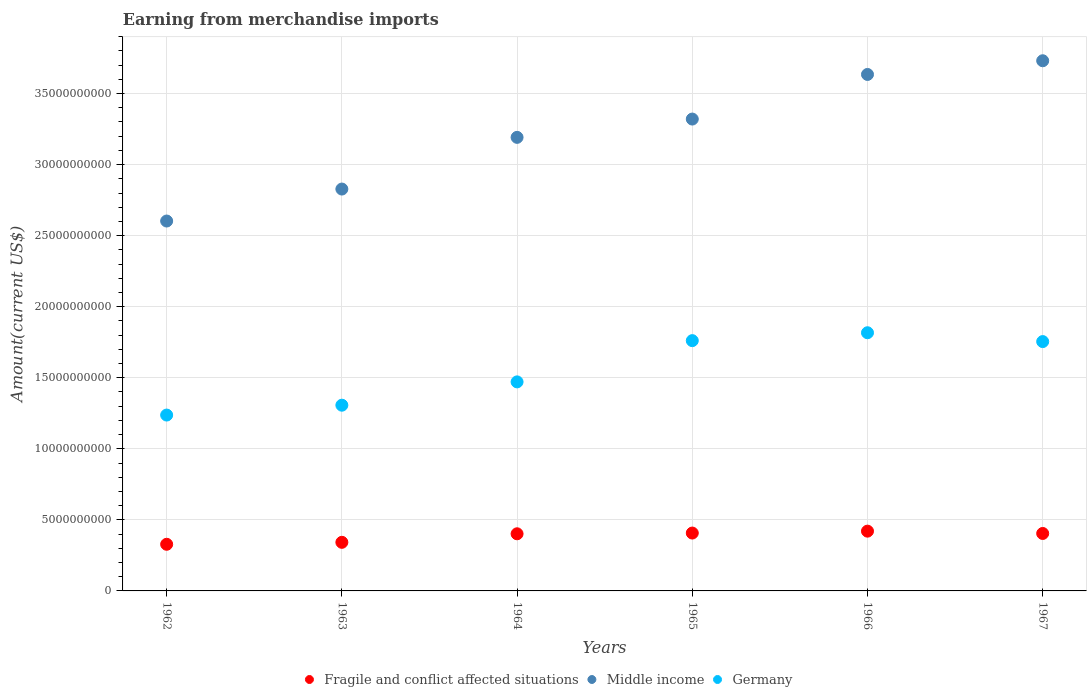How many different coloured dotlines are there?
Make the answer very short. 3. What is the amount earned from merchandise imports in Middle income in 1966?
Make the answer very short. 3.63e+1. Across all years, what is the maximum amount earned from merchandise imports in Germany?
Offer a very short reply. 1.82e+1. Across all years, what is the minimum amount earned from merchandise imports in Fragile and conflict affected situations?
Keep it short and to the point. 3.28e+09. In which year was the amount earned from merchandise imports in Germany maximum?
Give a very brief answer. 1966. What is the total amount earned from merchandise imports in Fragile and conflict affected situations in the graph?
Your answer should be very brief. 2.30e+1. What is the difference between the amount earned from merchandise imports in Germany in 1962 and that in 1965?
Offer a very short reply. -5.24e+09. What is the difference between the amount earned from merchandise imports in Middle income in 1962 and the amount earned from merchandise imports in Fragile and conflict affected situations in 1964?
Provide a succinct answer. 2.20e+1. What is the average amount earned from merchandise imports in Germany per year?
Your response must be concise. 1.56e+1. In the year 1967, what is the difference between the amount earned from merchandise imports in Middle income and amount earned from merchandise imports in Germany?
Provide a short and direct response. 1.98e+1. What is the ratio of the amount earned from merchandise imports in Fragile and conflict affected situations in 1962 to that in 1966?
Keep it short and to the point. 0.78. What is the difference between the highest and the second highest amount earned from merchandise imports in Germany?
Offer a very short reply. 5.55e+08. What is the difference between the highest and the lowest amount earned from merchandise imports in Germany?
Offer a terse response. 5.79e+09. Is it the case that in every year, the sum of the amount earned from merchandise imports in Fragile and conflict affected situations and amount earned from merchandise imports in Germany  is greater than the amount earned from merchandise imports in Middle income?
Keep it short and to the point. No. Does the amount earned from merchandise imports in Germany monotonically increase over the years?
Provide a succinct answer. No. Are the values on the major ticks of Y-axis written in scientific E-notation?
Offer a terse response. No. How many legend labels are there?
Your answer should be compact. 3. What is the title of the graph?
Give a very brief answer. Earning from merchandise imports. Does "Cote d'Ivoire" appear as one of the legend labels in the graph?
Provide a succinct answer. No. What is the label or title of the Y-axis?
Your response must be concise. Amount(current US$). What is the Amount(current US$) of Fragile and conflict affected situations in 1962?
Your response must be concise. 3.28e+09. What is the Amount(current US$) in Middle income in 1962?
Your answer should be compact. 2.60e+1. What is the Amount(current US$) in Germany in 1962?
Your answer should be very brief. 1.24e+1. What is the Amount(current US$) of Fragile and conflict affected situations in 1963?
Your response must be concise. 3.42e+09. What is the Amount(current US$) of Middle income in 1963?
Your answer should be compact. 2.83e+1. What is the Amount(current US$) of Germany in 1963?
Your response must be concise. 1.31e+1. What is the Amount(current US$) in Fragile and conflict affected situations in 1964?
Offer a very short reply. 4.02e+09. What is the Amount(current US$) in Middle income in 1964?
Offer a very short reply. 3.19e+1. What is the Amount(current US$) of Germany in 1964?
Offer a very short reply. 1.47e+1. What is the Amount(current US$) in Fragile and conflict affected situations in 1965?
Make the answer very short. 4.07e+09. What is the Amount(current US$) in Middle income in 1965?
Provide a short and direct response. 3.32e+1. What is the Amount(current US$) in Germany in 1965?
Provide a succinct answer. 1.76e+1. What is the Amount(current US$) of Fragile and conflict affected situations in 1966?
Give a very brief answer. 4.21e+09. What is the Amount(current US$) of Middle income in 1966?
Offer a very short reply. 3.63e+1. What is the Amount(current US$) of Germany in 1966?
Give a very brief answer. 1.82e+1. What is the Amount(current US$) of Fragile and conflict affected situations in 1967?
Provide a short and direct response. 4.04e+09. What is the Amount(current US$) in Middle income in 1967?
Your answer should be very brief. 3.73e+1. What is the Amount(current US$) in Germany in 1967?
Ensure brevity in your answer.  1.75e+1. Across all years, what is the maximum Amount(current US$) of Fragile and conflict affected situations?
Ensure brevity in your answer.  4.21e+09. Across all years, what is the maximum Amount(current US$) of Middle income?
Offer a very short reply. 3.73e+1. Across all years, what is the maximum Amount(current US$) of Germany?
Ensure brevity in your answer.  1.82e+1. Across all years, what is the minimum Amount(current US$) of Fragile and conflict affected situations?
Your response must be concise. 3.28e+09. Across all years, what is the minimum Amount(current US$) of Middle income?
Provide a succinct answer. 2.60e+1. Across all years, what is the minimum Amount(current US$) in Germany?
Offer a very short reply. 1.24e+1. What is the total Amount(current US$) of Fragile and conflict affected situations in the graph?
Offer a terse response. 2.30e+1. What is the total Amount(current US$) in Middle income in the graph?
Your answer should be very brief. 1.93e+11. What is the total Amount(current US$) of Germany in the graph?
Provide a succinct answer. 9.35e+1. What is the difference between the Amount(current US$) in Fragile and conflict affected situations in 1962 and that in 1963?
Provide a succinct answer. -1.38e+08. What is the difference between the Amount(current US$) in Middle income in 1962 and that in 1963?
Your answer should be very brief. -2.25e+09. What is the difference between the Amount(current US$) of Germany in 1962 and that in 1963?
Give a very brief answer. -6.94e+08. What is the difference between the Amount(current US$) of Fragile and conflict affected situations in 1962 and that in 1964?
Keep it short and to the point. -7.38e+08. What is the difference between the Amount(current US$) of Middle income in 1962 and that in 1964?
Ensure brevity in your answer.  -5.89e+09. What is the difference between the Amount(current US$) in Germany in 1962 and that in 1964?
Provide a succinct answer. -2.33e+09. What is the difference between the Amount(current US$) of Fragile and conflict affected situations in 1962 and that in 1965?
Make the answer very short. -7.90e+08. What is the difference between the Amount(current US$) in Middle income in 1962 and that in 1965?
Your answer should be compact. -7.17e+09. What is the difference between the Amount(current US$) in Germany in 1962 and that in 1965?
Your answer should be compact. -5.24e+09. What is the difference between the Amount(current US$) in Fragile and conflict affected situations in 1962 and that in 1966?
Make the answer very short. -9.24e+08. What is the difference between the Amount(current US$) in Middle income in 1962 and that in 1966?
Keep it short and to the point. -1.03e+1. What is the difference between the Amount(current US$) in Germany in 1962 and that in 1966?
Provide a succinct answer. -5.79e+09. What is the difference between the Amount(current US$) of Fragile and conflict affected situations in 1962 and that in 1967?
Provide a succinct answer. -7.61e+08. What is the difference between the Amount(current US$) of Middle income in 1962 and that in 1967?
Give a very brief answer. -1.13e+1. What is the difference between the Amount(current US$) in Germany in 1962 and that in 1967?
Offer a very short reply. -5.17e+09. What is the difference between the Amount(current US$) in Fragile and conflict affected situations in 1963 and that in 1964?
Provide a succinct answer. -6.00e+08. What is the difference between the Amount(current US$) in Middle income in 1963 and that in 1964?
Offer a very short reply. -3.64e+09. What is the difference between the Amount(current US$) in Germany in 1963 and that in 1964?
Your answer should be very brief. -1.64e+09. What is the difference between the Amount(current US$) in Fragile and conflict affected situations in 1963 and that in 1965?
Provide a short and direct response. -6.53e+08. What is the difference between the Amount(current US$) in Middle income in 1963 and that in 1965?
Your answer should be very brief. -4.93e+09. What is the difference between the Amount(current US$) of Germany in 1963 and that in 1965?
Your response must be concise. -4.54e+09. What is the difference between the Amount(current US$) in Fragile and conflict affected situations in 1963 and that in 1966?
Offer a very short reply. -7.86e+08. What is the difference between the Amount(current US$) of Middle income in 1963 and that in 1966?
Offer a very short reply. -8.06e+09. What is the difference between the Amount(current US$) of Germany in 1963 and that in 1966?
Your answer should be compact. -5.10e+09. What is the difference between the Amount(current US$) in Fragile and conflict affected situations in 1963 and that in 1967?
Provide a succinct answer. -6.23e+08. What is the difference between the Amount(current US$) in Middle income in 1963 and that in 1967?
Give a very brief answer. -9.03e+09. What is the difference between the Amount(current US$) of Germany in 1963 and that in 1967?
Provide a short and direct response. -4.48e+09. What is the difference between the Amount(current US$) in Fragile and conflict affected situations in 1964 and that in 1965?
Keep it short and to the point. -5.24e+07. What is the difference between the Amount(current US$) of Middle income in 1964 and that in 1965?
Make the answer very short. -1.29e+09. What is the difference between the Amount(current US$) in Germany in 1964 and that in 1965?
Your answer should be very brief. -2.90e+09. What is the difference between the Amount(current US$) in Fragile and conflict affected situations in 1964 and that in 1966?
Make the answer very short. -1.86e+08. What is the difference between the Amount(current US$) of Middle income in 1964 and that in 1966?
Keep it short and to the point. -4.43e+09. What is the difference between the Amount(current US$) of Germany in 1964 and that in 1966?
Ensure brevity in your answer.  -3.46e+09. What is the difference between the Amount(current US$) in Fragile and conflict affected situations in 1964 and that in 1967?
Give a very brief answer. -2.29e+07. What is the difference between the Amount(current US$) of Middle income in 1964 and that in 1967?
Your response must be concise. -5.39e+09. What is the difference between the Amount(current US$) in Germany in 1964 and that in 1967?
Keep it short and to the point. -2.84e+09. What is the difference between the Amount(current US$) of Fragile and conflict affected situations in 1965 and that in 1966?
Provide a succinct answer. -1.33e+08. What is the difference between the Amount(current US$) of Middle income in 1965 and that in 1966?
Your answer should be compact. -3.14e+09. What is the difference between the Amount(current US$) in Germany in 1965 and that in 1966?
Provide a short and direct response. -5.55e+08. What is the difference between the Amount(current US$) of Fragile and conflict affected situations in 1965 and that in 1967?
Ensure brevity in your answer.  2.96e+07. What is the difference between the Amount(current US$) in Middle income in 1965 and that in 1967?
Your response must be concise. -4.10e+09. What is the difference between the Amount(current US$) of Germany in 1965 and that in 1967?
Your answer should be compact. 6.65e+07. What is the difference between the Amount(current US$) of Fragile and conflict affected situations in 1966 and that in 1967?
Your response must be concise. 1.63e+08. What is the difference between the Amount(current US$) of Middle income in 1966 and that in 1967?
Your answer should be compact. -9.64e+08. What is the difference between the Amount(current US$) in Germany in 1966 and that in 1967?
Your response must be concise. 6.22e+08. What is the difference between the Amount(current US$) of Fragile and conflict affected situations in 1962 and the Amount(current US$) of Middle income in 1963?
Your response must be concise. -2.50e+1. What is the difference between the Amount(current US$) in Fragile and conflict affected situations in 1962 and the Amount(current US$) in Germany in 1963?
Ensure brevity in your answer.  -9.79e+09. What is the difference between the Amount(current US$) of Middle income in 1962 and the Amount(current US$) of Germany in 1963?
Make the answer very short. 1.30e+1. What is the difference between the Amount(current US$) in Fragile and conflict affected situations in 1962 and the Amount(current US$) in Middle income in 1964?
Your answer should be very brief. -2.86e+1. What is the difference between the Amount(current US$) of Fragile and conflict affected situations in 1962 and the Amount(current US$) of Germany in 1964?
Give a very brief answer. -1.14e+1. What is the difference between the Amount(current US$) in Middle income in 1962 and the Amount(current US$) in Germany in 1964?
Ensure brevity in your answer.  1.13e+1. What is the difference between the Amount(current US$) in Fragile and conflict affected situations in 1962 and the Amount(current US$) in Middle income in 1965?
Provide a succinct answer. -2.99e+1. What is the difference between the Amount(current US$) in Fragile and conflict affected situations in 1962 and the Amount(current US$) in Germany in 1965?
Your answer should be very brief. -1.43e+1. What is the difference between the Amount(current US$) in Middle income in 1962 and the Amount(current US$) in Germany in 1965?
Your answer should be compact. 8.42e+09. What is the difference between the Amount(current US$) in Fragile and conflict affected situations in 1962 and the Amount(current US$) in Middle income in 1966?
Offer a terse response. -3.31e+1. What is the difference between the Amount(current US$) in Fragile and conflict affected situations in 1962 and the Amount(current US$) in Germany in 1966?
Provide a short and direct response. -1.49e+1. What is the difference between the Amount(current US$) of Middle income in 1962 and the Amount(current US$) of Germany in 1966?
Provide a short and direct response. 7.86e+09. What is the difference between the Amount(current US$) of Fragile and conflict affected situations in 1962 and the Amount(current US$) of Middle income in 1967?
Your response must be concise. -3.40e+1. What is the difference between the Amount(current US$) in Fragile and conflict affected situations in 1962 and the Amount(current US$) in Germany in 1967?
Offer a very short reply. -1.43e+1. What is the difference between the Amount(current US$) of Middle income in 1962 and the Amount(current US$) of Germany in 1967?
Your answer should be compact. 8.48e+09. What is the difference between the Amount(current US$) in Fragile and conflict affected situations in 1963 and the Amount(current US$) in Middle income in 1964?
Keep it short and to the point. -2.85e+1. What is the difference between the Amount(current US$) of Fragile and conflict affected situations in 1963 and the Amount(current US$) of Germany in 1964?
Offer a terse response. -1.13e+1. What is the difference between the Amount(current US$) in Middle income in 1963 and the Amount(current US$) in Germany in 1964?
Make the answer very short. 1.36e+1. What is the difference between the Amount(current US$) of Fragile and conflict affected situations in 1963 and the Amount(current US$) of Middle income in 1965?
Offer a terse response. -2.98e+1. What is the difference between the Amount(current US$) of Fragile and conflict affected situations in 1963 and the Amount(current US$) of Germany in 1965?
Your response must be concise. -1.42e+1. What is the difference between the Amount(current US$) in Middle income in 1963 and the Amount(current US$) in Germany in 1965?
Your answer should be compact. 1.07e+1. What is the difference between the Amount(current US$) in Fragile and conflict affected situations in 1963 and the Amount(current US$) in Middle income in 1966?
Provide a short and direct response. -3.29e+1. What is the difference between the Amount(current US$) in Fragile and conflict affected situations in 1963 and the Amount(current US$) in Germany in 1966?
Give a very brief answer. -1.47e+1. What is the difference between the Amount(current US$) in Middle income in 1963 and the Amount(current US$) in Germany in 1966?
Offer a terse response. 1.01e+1. What is the difference between the Amount(current US$) in Fragile and conflict affected situations in 1963 and the Amount(current US$) in Middle income in 1967?
Your answer should be very brief. -3.39e+1. What is the difference between the Amount(current US$) of Fragile and conflict affected situations in 1963 and the Amount(current US$) of Germany in 1967?
Your answer should be very brief. -1.41e+1. What is the difference between the Amount(current US$) in Middle income in 1963 and the Amount(current US$) in Germany in 1967?
Give a very brief answer. 1.07e+1. What is the difference between the Amount(current US$) of Fragile and conflict affected situations in 1964 and the Amount(current US$) of Middle income in 1965?
Your answer should be compact. -2.92e+1. What is the difference between the Amount(current US$) of Fragile and conflict affected situations in 1964 and the Amount(current US$) of Germany in 1965?
Offer a terse response. -1.36e+1. What is the difference between the Amount(current US$) of Middle income in 1964 and the Amount(current US$) of Germany in 1965?
Ensure brevity in your answer.  1.43e+1. What is the difference between the Amount(current US$) in Fragile and conflict affected situations in 1964 and the Amount(current US$) in Middle income in 1966?
Make the answer very short. -3.23e+1. What is the difference between the Amount(current US$) in Fragile and conflict affected situations in 1964 and the Amount(current US$) in Germany in 1966?
Offer a very short reply. -1.41e+1. What is the difference between the Amount(current US$) of Middle income in 1964 and the Amount(current US$) of Germany in 1966?
Ensure brevity in your answer.  1.37e+1. What is the difference between the Amount(current US$) in Fragile and conflict affected situations in 1964 and the Amount(current US$) in Middle income in 1967?
Make the answer very short. -3.33e+1. What is the difference between the Amount(current US$) in Fragile and conflict affected situations in 1964 and the Amount(current US$) in Germany in 1967?
Keep it short and to the point. -1.35e+1. What is the difference between the Amount(current US$) in Middle income in 1964 and the Amount(current US$) in Germany in 1967?
Your answer should be compact. 1.44e+1. What is the difference between the Amount(current US$) in Fragile and conflict affected situations in 1965 and the Amount(current US$) in Middle income in 1966?
Offer a very short reply. -3.23e+1. What is the difference between the Amount(current US$) in Fragile and conflict affected situations in 1965 and the Amount(current US$) in Germany in 1966?
Your response must be concise. -1.41e+1. What is the difference between the Amount(current US$) of Middle income in 1965 and the Amount(current US$) of Germany in 1966?
Your answer should be very brief. 1.50e+1. What is the difference between the Amount(current US$) of Fragile and conflict affected situations in 1965 and the Amount(current US$) of Middle income in 1967?
Offer a terse response. -3.32e+1. What is the difference between the Amount(current US$) in Fragile and conflict affected situations in 1965 and the Amount(current US$) in Germany in 1967?
Your answer should be very brief. -1.35e+1. What is the difference between the Amount(current US$) of Middle income in 1965 and the Amount(current US$) of Germany in 1967?
Ensure brevity in your answer.  1.57e+1. What is the difference between the Amount(current US$) of Fragile and conflict affected situations in 1966 and the Amount(current US$) of Middle income in 1967?
Ensure brevity in your answer.  -3.31e+1. What is the difference between the Amount(current US$) of Fragile and conflict affected situations in 1966 and the Amount(current US$) of Germany in 1967?
Give a very brief answer. -1.33e+1. What is the difference between the Amount(current US$) of Middle income in 1966 and the Amount(current US$) of Germany in 1967?
Ensure brevity in your answer.  1.88e+1. What is the average Amount(current US$) of Fragile and conflict affected situations per year?
Provide a succinct answer. 3.84e+09. What is the average Amount(current US$) in Middle income per year?
Offer a very short reply. 3.22e+1. What is the average Amount(current US$) in Germany per year?
Give a very brief answer. 1.56e+1. In the year 1962, what is the difference between the Amount(current US$) in Fragile and conflict affected situations and Amount(current US$) in Middle income?
Your response must be concise. -2.27e+1. In the year 1962, what is the difference between the Amount(current US$) in Fragile and conflict affected situations and Amount(current US$) in Germany?
Provide a succinct answer. -9.09e+09. In the year 1962, what is the difference between the Amount(current US$) of Middle income and Amount(current US$) of Germany?
Offer a terse response. 1.37e+1. In the year 1963, what is the difference between the Amount(current US$) of Fragile and conflict affected situations and Amount(current US$) of Middle income?
Offer a terse response. -2.49e+1. In the year 1963, what is the difference between the Amount(current US$) of Fragile and conflict affected situations and Amount(current US$) of Germany?
Keep it short and to the point. -9.65e+09. In the year 1963, what is the difference between the Amount(current US$) of Middle income and Amount(current US$) of Germany?
Make the answer very short. 1.52e+1. In the year 1964, what is the difference between the Amount(current US$) of Fragile and conflict affected situations and Amount(current US$) of Middle income?
Ensure brevity in your answer.  -2.79e+1. In the year 1964, what is the difference between the Amount(current US$) of Fragile and conflict affected situations and Amount(current US$) of Germany?
Your response must be concise. -1.07e+1. In the year 1964, what is the difference between the Amount(current US$) in Middle income and Amount(current US$) in Germany?
Make the answer very short. 1.72e+1. In the year 1965, what is the difference between the Amount(current US$) in Fragile and conflict affected situations and Amount(current US$) in Middle income?
Offer a very short reply. -2.91e+1. In the year 1965, what is the difference between the Amount(current US$) of Fragile and conflict affected situations and Amount(current US$) of Germany?
Your answer should be very brief. -1.35e+1. In the year 1965, what is the difference between the Amount(current US$) of Middle income and Amount(current US$) of Germany?
Ensure brevity in your answer.  1.56e+1. In the year 1966, what is the difference between the Amount(current US$) in Fragile and conflict affected situations and Amount(current US$) in Middle income?
Your answer should be very brief. -3.21e+1. In the year 1966, what is the difference between the Amount(current US$) in Fragile and conflict affected situations and Amount(current US$) in Germany?
Make the answer very short. -1.40e+1. In the year 1966, what is the difference between the Amount(current US$) in Middle income and Amount(current US$) in Germany?
Offer a very short reply. 1.82e+1. In the year 1967, what is the difference between the Amount(current US$) of Fragile and conflict affected situations and Amount(current US$) of Middle income?
Offer a very short reply. -3.33e+1. In the year 1967, what is the difference between the Amount(current US$) in Fragile and conflict affected situations and Amount(current US$) in Germany?
Offer a very short reply. -1.35e+1. In the year 1967, what is the difference between the Amount(current US$) of Middle income and Amount(current US$) of Germany?
Ensure brevity in your answer.  1.98e+1. What is the ratio of the Amount(current US$) in Fragile and conflict affected situations in 1962 to that in 1963?
Give a very brief answer. 0.96. What is the ratio of the Amount(current US$) in Middle income in 1962 to that in 1963?
Offer a terse response. 0.92. What is the ratio of the Amount(current US$) of Germany in 1962 to that in 1963?
Give a very brief answer. 0.95. What is the ratio of the Amount(current US$) in Fragile and conflict affected situations in 1962 to that in 1964?
Your answer should be compact. 0.82. What is the ratio of the Amount(current US$) of Middle income in 1962 to that in 1964?
Your answer should be compact. 0.82. What is the ratio of the Amount(current US$) in Germany in 1962 to that in 1964?
Offer a terse response. 0.84. What is the ratio of the Amount(current US$) of Fragile and conflict affected situations in 1962 to that in 1965?
Your response must be concise. 0.81. What is the ratio of the Amount(current US$) of Middle income in 1962 to that in 1965?
Your response must be concise. 0.78. What is the ratio of the Amount(current US$) in Germany in 1962 to that in 1965?
Provide a succinct answer. 0.7. What is the ratio of the Amount(current US$) of Fragile and conflict affected situations in 1962 to that in 1966?
Give a very brief answer. 0.78. What is the ratio of the Amount(current US$) in Middle income in 1962 to that in 1966?
Keep it short and to the point. 0.72. What is the ratio of the Amount(current US$) in Germany in 1962 to that in 1966?
Your response must be concise. 0.68. What is the ratio of the Amount(current US$) of Fragile and conflict affected situations in 1962 to that in 1967?
Your response must be concise. 0.81. What is the ratio of the Amount(current US$) of Middle income in 1962 to that in 1967?
Your answer should be compact. 0.7. What is the ratio of the Amount(current US$) of Germany in 1962 to that in 1967?
Offer a terse response. 0.71. What is the ratio of the Amount(current US$) in Fragile and conflict affected situations in 1963 to that in 1964?
Provide a short and direct response. 0.85. What is the ratio of the Amount(current US$) of Middle income in 1963 to that in 1964?
Offer a very short reply. 0.89. What is the ratio of the Amount(current US$) in Germany in 1963 to that in 1964?
Give a very brief answer. 0.89. What is the ratio of the Amount(current US$) in Fragile and conflict affected situations in 1963 to that in 1965?
Provide a succinct answer. 0.84. What is the ratio of the Amount(current US$) of Middle income in 1963 to that in 1965?
Offer a very short reply. 0.85. What is the ratio of the Amount(current US$) of Germany in 1963 to that in 1965?
Your response must be concise. 0.74. What is the ratio of the Amount(current US$) in Fragile and conflict affected situations in 1963 to that in 1966?
Offer a very short reply. 0.81. What is the ratio of the Amount(current US$) in Middle income in 1963 to that in 1966?
Keep it short and to the point. 0.78. What is the ratio of the Amount(current US$) in Germany in 1963 to that in 1966?
Provide a short and direct response. 0.72. What is the ratio of the Amount(current US$) in Fragile and conflict affected situations in 1963 to that in 1967?
Offer a terse response. 0.85. What is the ratio of the Amount(current US$) of Middle income in 1963 to that in 1967?
Your answer should be very brief. 0.76. What is the ratio of the Amount(current US$) of Germany in 1963 to that in 1967?
Provide a short and direct response. 0.74. What is the ratio of the Amount(current US$) in Fragile and conflict affected situations in 1964 to that in 1965?
Offer a very short reply. 0.99. What is the ratio of the Amount(current US$) in Middle income in 1964 to that in 1965?
Ensure brevity in your answer.  0.96. What is the ratio of the Amount(current US$) in Germany in 1964 to that in 1965?
Your answer should be very brief. 0.84. What is the ratio of the Amount(current US$) in Fragile and conflict affected situations in 1964 to that in 1966?
Your answer should be very brief. 0.96. What is the ratio of the Amount(current US$) in Middle income in 1964 to that in 1966?
Your answer should be very brief. 0.88. What is the ratio of the Amount(current US$) in Germany in 1964 to that in 1966?
Make the answer very short. 0.81. What is the ratio of the Amount(current US$) of Middle income in 1964 to that in 1967?
Your answer should be compact. 0.86. What is the ratio of the Amount(current US$) of Germany in 1964 to that in 1967?
Your answer should be compact. 0.84. What is the ratio of the Amount(current US$) of Fragile and conflict affected situations in 1965 to that in 1966?
Provide a short and direct response. 0.97. What is the ratio of the Amount(current US$) of Middle income in 1965 to that in 1966?
Ensure brevity in your answer.  0.91. What is the ratio of the Amount(current US$) of Germany in 1965 to that in 1966?
Give a very brief answer. 0.97. What is the ratio of the Amount(current US$) in Fragile and conflict affected situations in 1965 to that in 1967?
Your response must be concise. 1.01. What is the ratio of the Amount(current US$) of Middle income in 1965 to that in 1967?
Your response must be concise. 0.89. What is the ratio of the Amount(current US$) of Germany in 1965 to that in 1967?
Your answer should be very brief. 1. What is the ratio of the Amount(current US$) of Fragile and conflict affected situations in 1966 to that in 1967?
Your answer should be compact. 1.04. What is the ratio of the Amount(current US$) of Middle income in 1966 to that in 1967?
Provide a short and direct response. 0.97. What is the ratio of the Amount(current US$) in Germany in 1966 to that in 1967?
Your answer should be very brief. 1.04. What is the difference between the highest and the second highest Amount(current US$) of Fragile and conflict affected situations?
Give a very brief answer. 1.33e+08. What is the difference between the highest and the second highest Amount(current US$) in Middle income?
Your response must be concise. 9.64e+08. What is the difference between the highest and the second highest Amount(current US$) in Germany?
Provide a short and direct response. 5.55e+08. What is the difference between the highest and the lowest Amount(current US$) of Fragile and conflict affected situations?
Offer a terse response. 9.24e+08. What is the difference between the highest and the lowest Amount(current US$) of Middle income?
Offer a terse response. 1.13e+1. What is the difference between the highest and the lowest Amount(current US$) in Germany?
Give a very brief answer. 5.79e+09. 